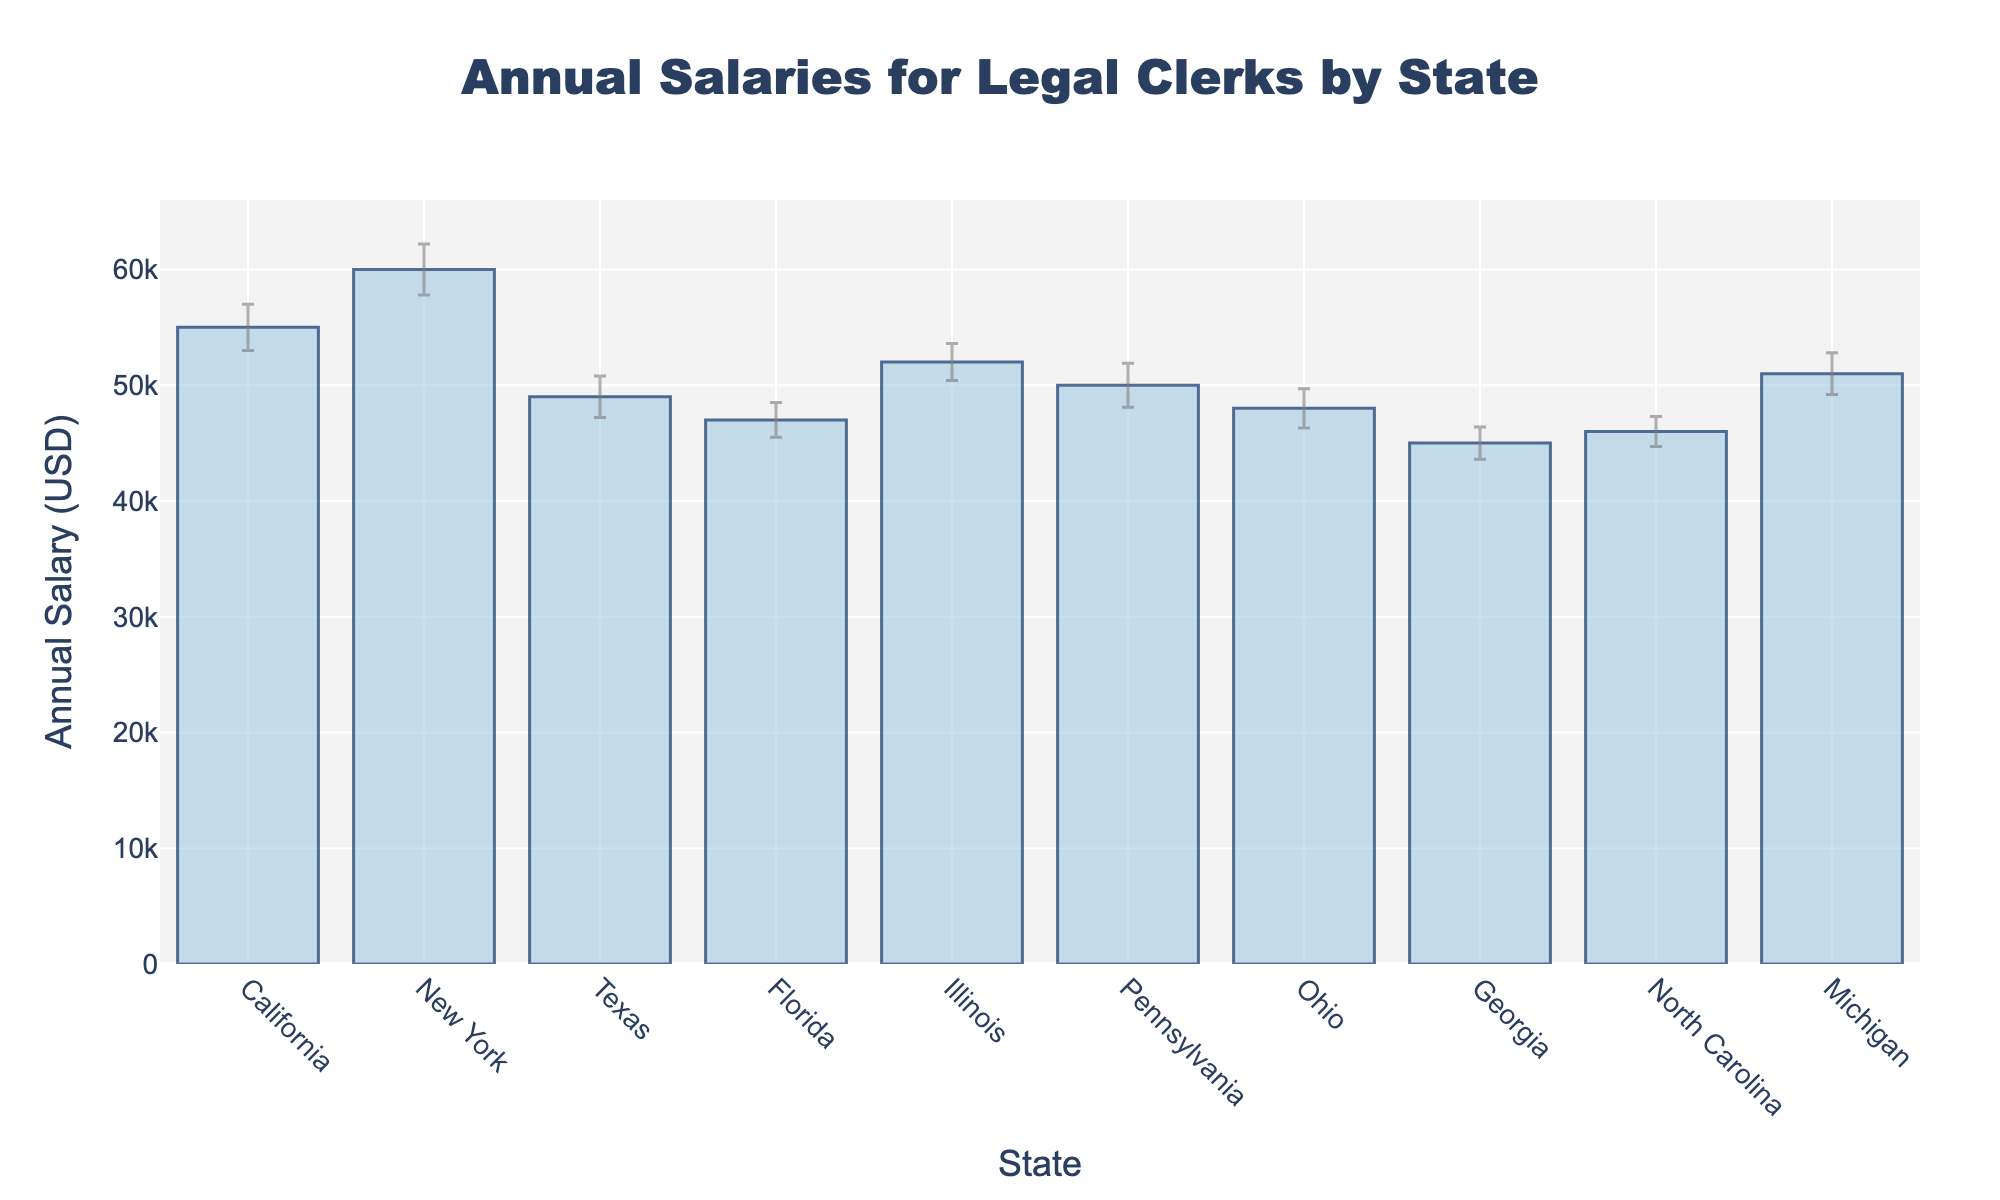what is the title of the bar chart? The title of the bar chart is displayed at the top center of the figure, typically in a larger and bold font, and reads "Annual Salaries for Legal Clerks by State".
Answer: Annual Salaries for Legal Clerks by State How many states are represented in the bar chart? By counting the bars or looking at the labels on the x-axis, we can see that there are bars for California, New York, Texas, Florida, Illinois, Pennsylvania, Ohio, Georgia, North Carolina, and Michigan, which totals 10 states.
Answer: 10 Which state has the highest annual salary for legal clerks? By comparing the heights of the bars, the tallest bar represents New York, indicating it has the highest annual salary among the states listed.
Answer: New York What is the range of annual salaries shown in the chart? The maximum annual salary is for New York ($60,000) and the minimum is for Georgia ($45,000); thus, the range is $60,000 - $45,000.
Answer: $15,000 Which two states have the smallest difference in their annual salaries? We need to find two bars that are closest in height. Illinois ($52,000) and Pennsylvania ($50,000) have a small difference of $2,000.
Answer: Illinois and Pennsylvania How is the standard error represented in the chart? The standard error is represented by vertical lines (error bars) coming out of the top of each bar. These lines indicate the variability or error margin in the salary data.
Answer: Error bars How much more is the annual salary in California compared to Texas? By looking at the height of the bars, California's salary is $55,000, and Texas's is $49,000. The difference is $55,000 - $49,000.
Answer: $6,000 Which state has the largest standard error, and what is its value? The error bars represent standard error, and the longest error bar is found in New York, indicating the largest standard error. Its value is $2,200.
Answer: New York, $2,200 Which state has the lowest annual salary? The bar with the lowest height represents Georgia, which also has its value labeled as $45,000.
Answer: Georgia If you remove the state with the highest salary, what is the new average salary for the remaining states? The salaries without New York are $55,000 (CA), $49,000 (TX), $47,000 (FL), $52,000 (IL), $50,000 (PA), $48,000 (OH), $45,000 (GA), $46,000 (NC), $51,000 (MI). Summing these values gives $443,000, and dividing by 9 gives $49,222.
Answer: $49,222 